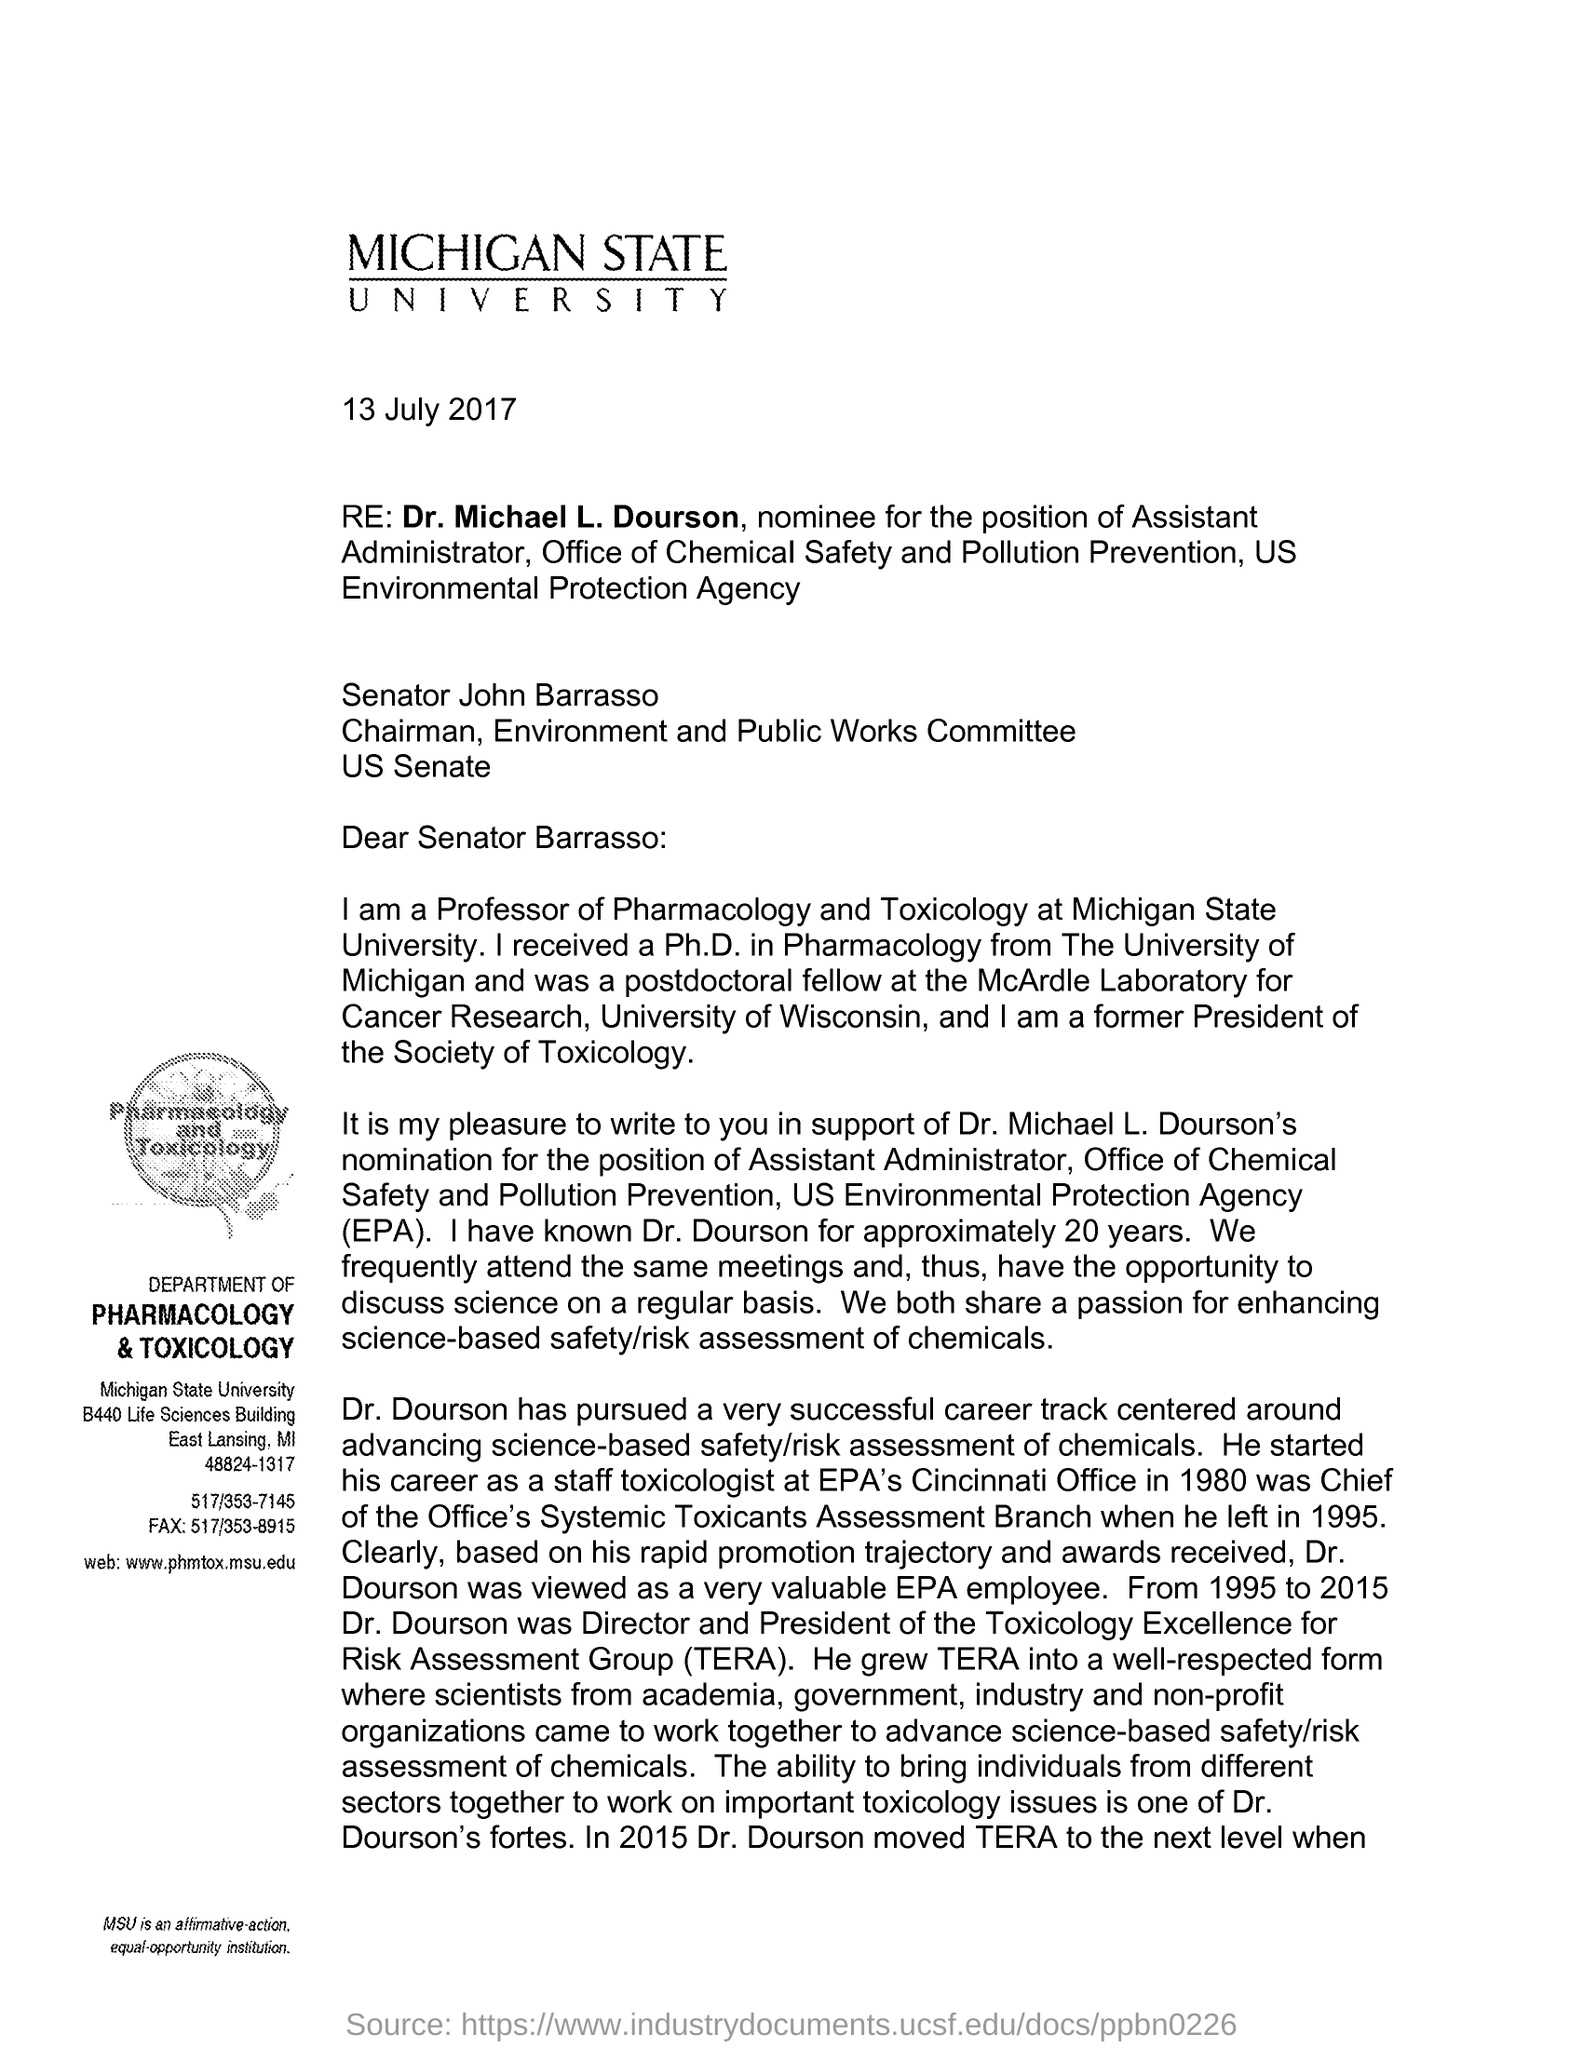Which University is mentioned in the letter head?
Provide a succinct answer. MICHIGAN STATE UNIVERSITY. What is the fullform of EPA?
Your response must be concise. Environmental Protection Agency. Who was the Director and President of the TERA from 1995 to 2015?
Offer a terse response. Dr. Michael L. Dourson. What is the fullform of TERA?
Offer a terse response. Toxicology Excellence for Risk Assessment Group. What is the website of the Department of Pharmacology & Toxicology, Michigan State University?
Offer a terse response. Web: www.phmtox.msu.edu. 